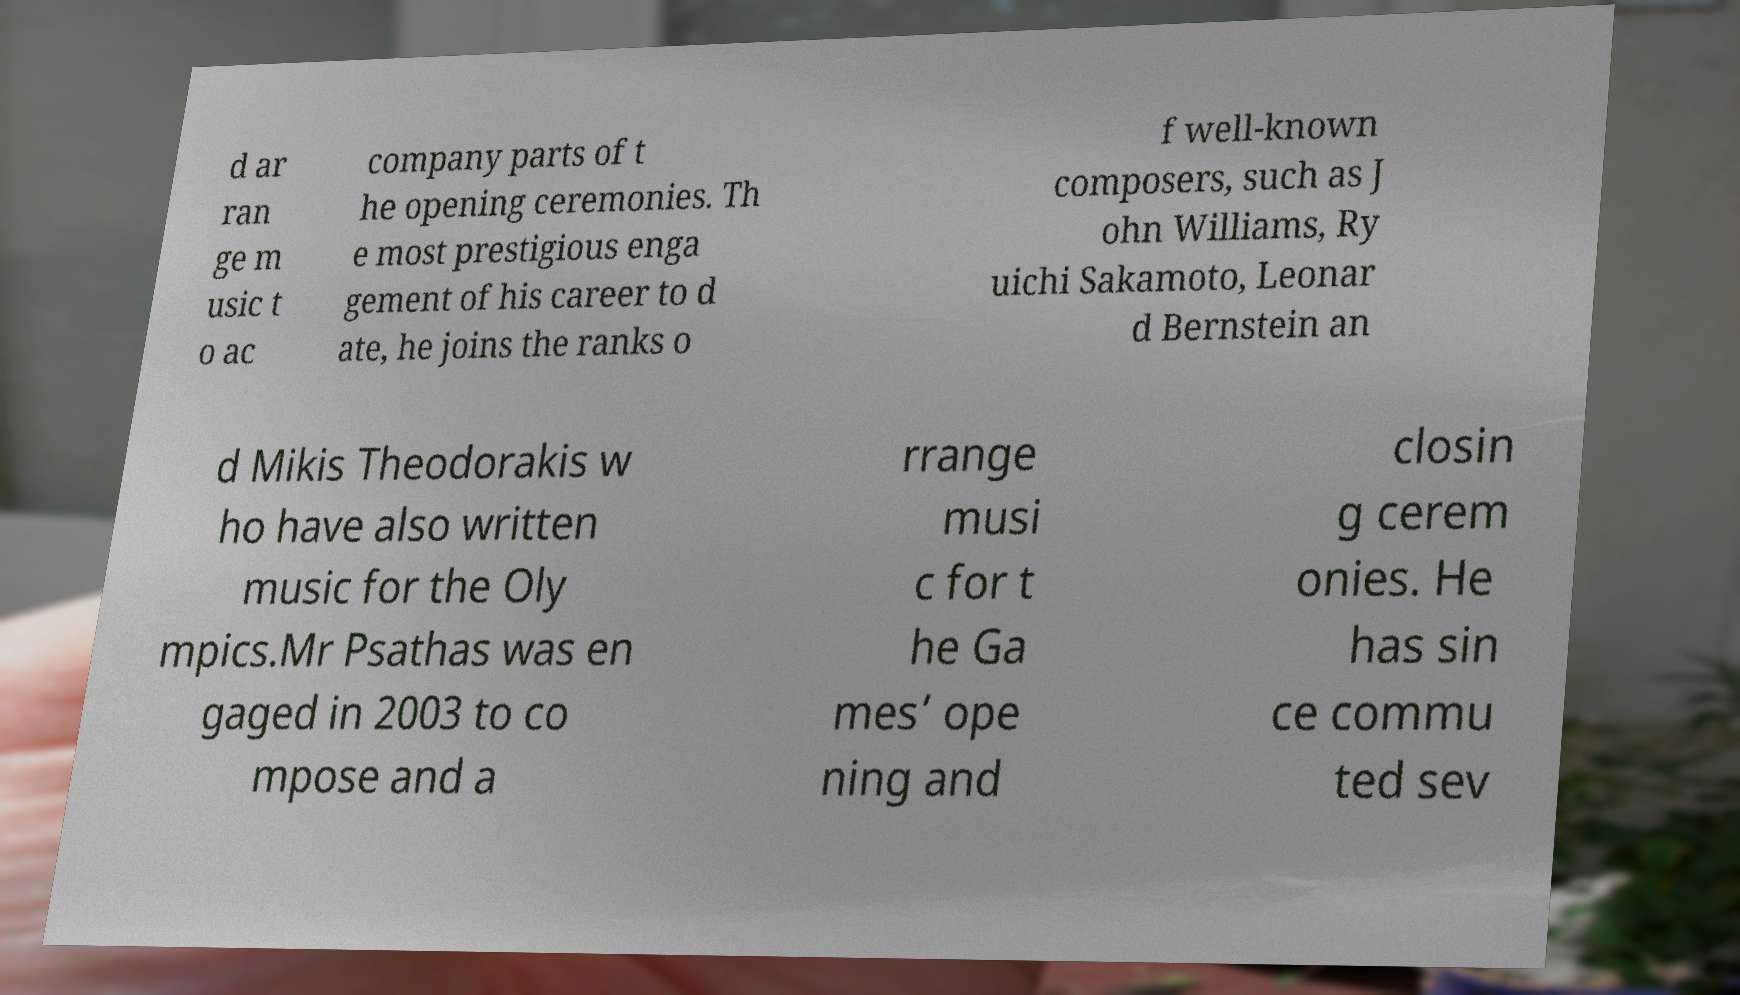Please read and relay the text visible in this image. What does it say? d ar ran ge m usic t o ac company parts of t he opening ceremonies. Th e most prestigious enga gement of his career to d ate, he joins the ranks o f well-known composers, such as J ohn Williams, Ry uichi Sakamoto, Leonar d Bernstein an d Mikis Theodorakis w ho have also written music for the Oly mpics.Mr Psathas was en gaged in 2003 to co mpose and a rrange musi c for t he Ga mes’ ope ning and closin g cerem onies. He has sin ce commu ted sev 